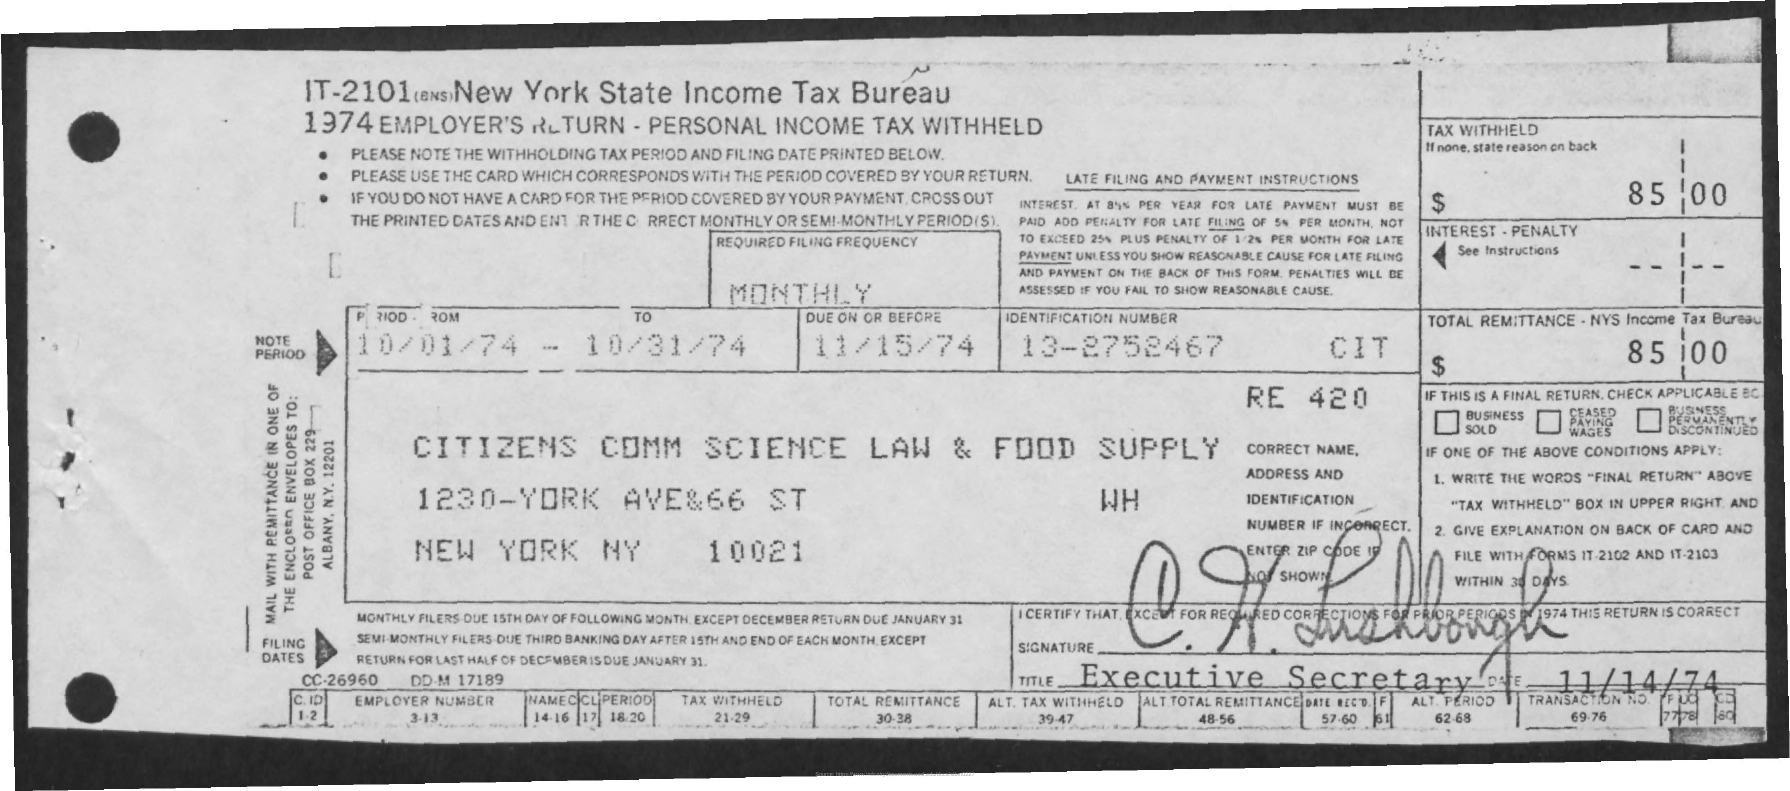Draw attention to some important aspects in this diagram. The amount mentioned is 85.00. 